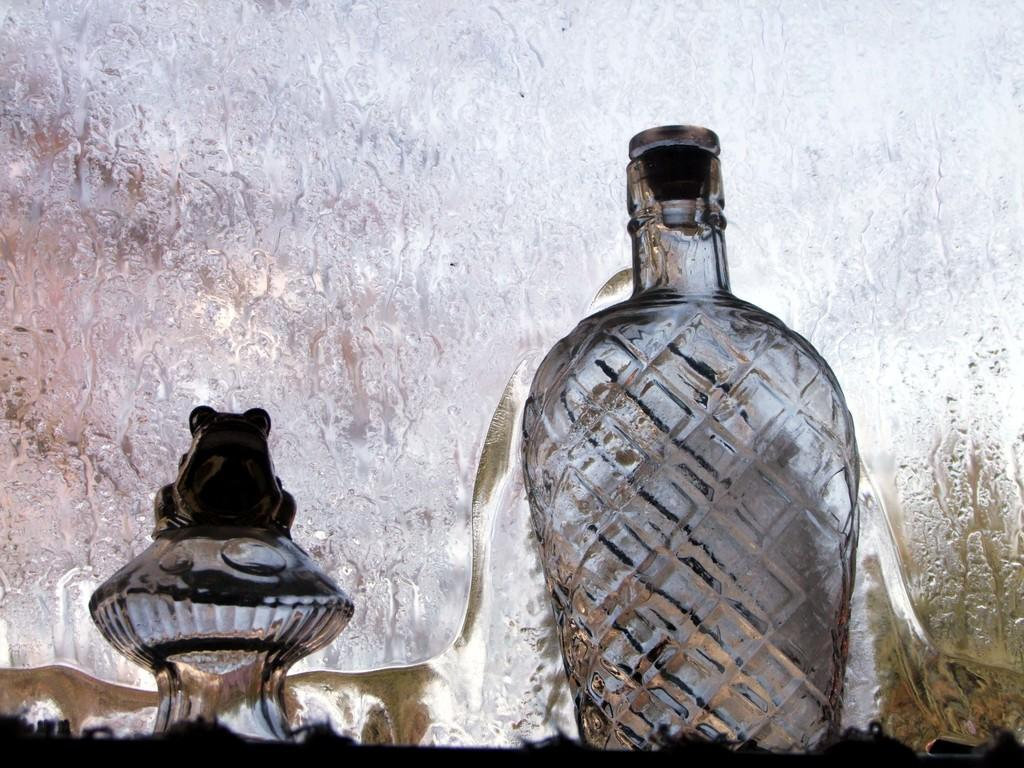What type of container is visible in the image? There is a glass bottle in the image. What material is the object made of in the image? The object in the image is made of glass. What type of grass is growing on the sofa in the image? There is no grass or sofa present in the image; it only features a glass bottle and an object made of glass. 